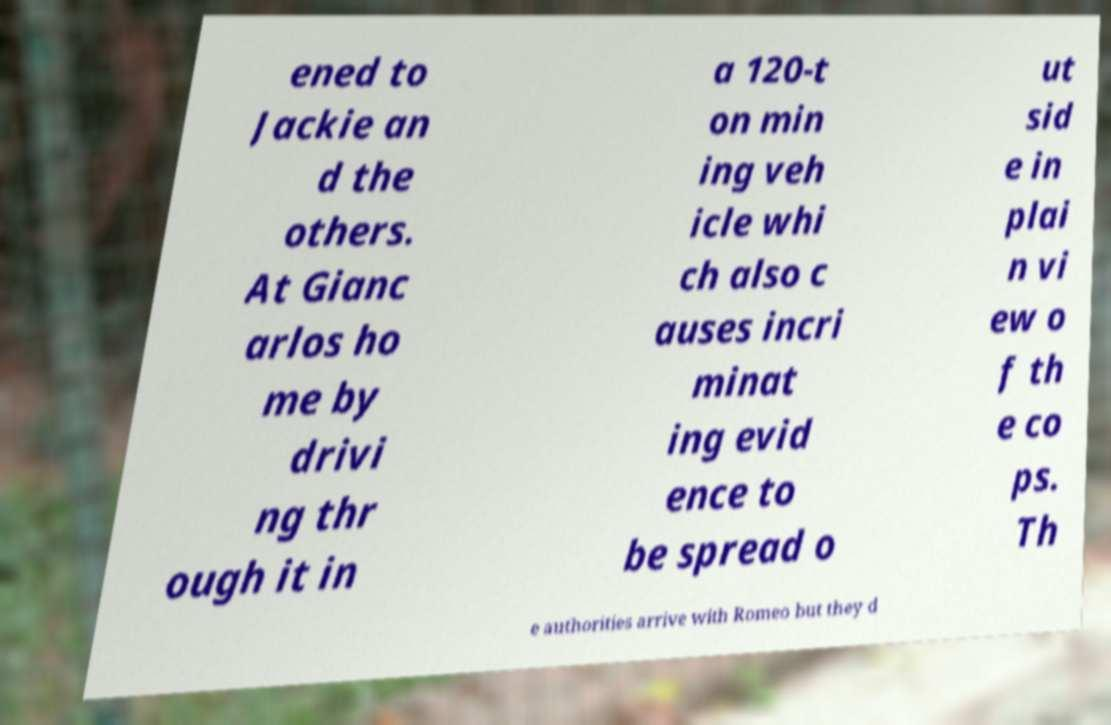For documentation purposes, I need the text within this image transcribed. Could you provide that? ened to Jackie an d the others. At Gianc arlos ho me by drivi ng thr ough it in a 120-t on min ing veh icle whi ch also c auses incri minat ing evid ence to be spread o ut sid e in plai n vi ew o f th e co ps. Th e authorities arrive with Romeo but they d 